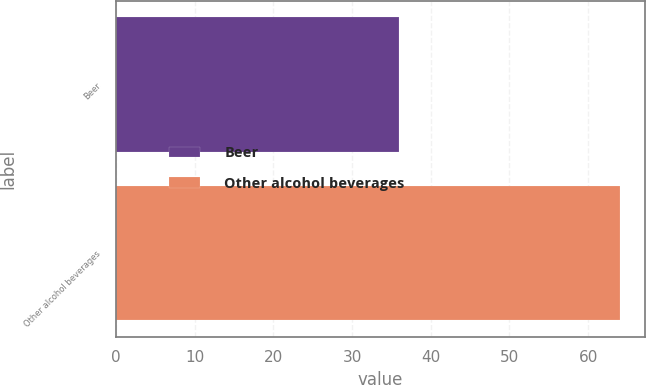Convert chart. <chart><loc_0><loc_0><loc_500><loc_500><bar_chart><fcel>Beer<fcel>Other alcohol beverages<nl><fcel>36<fcel>64<nl></chart> 